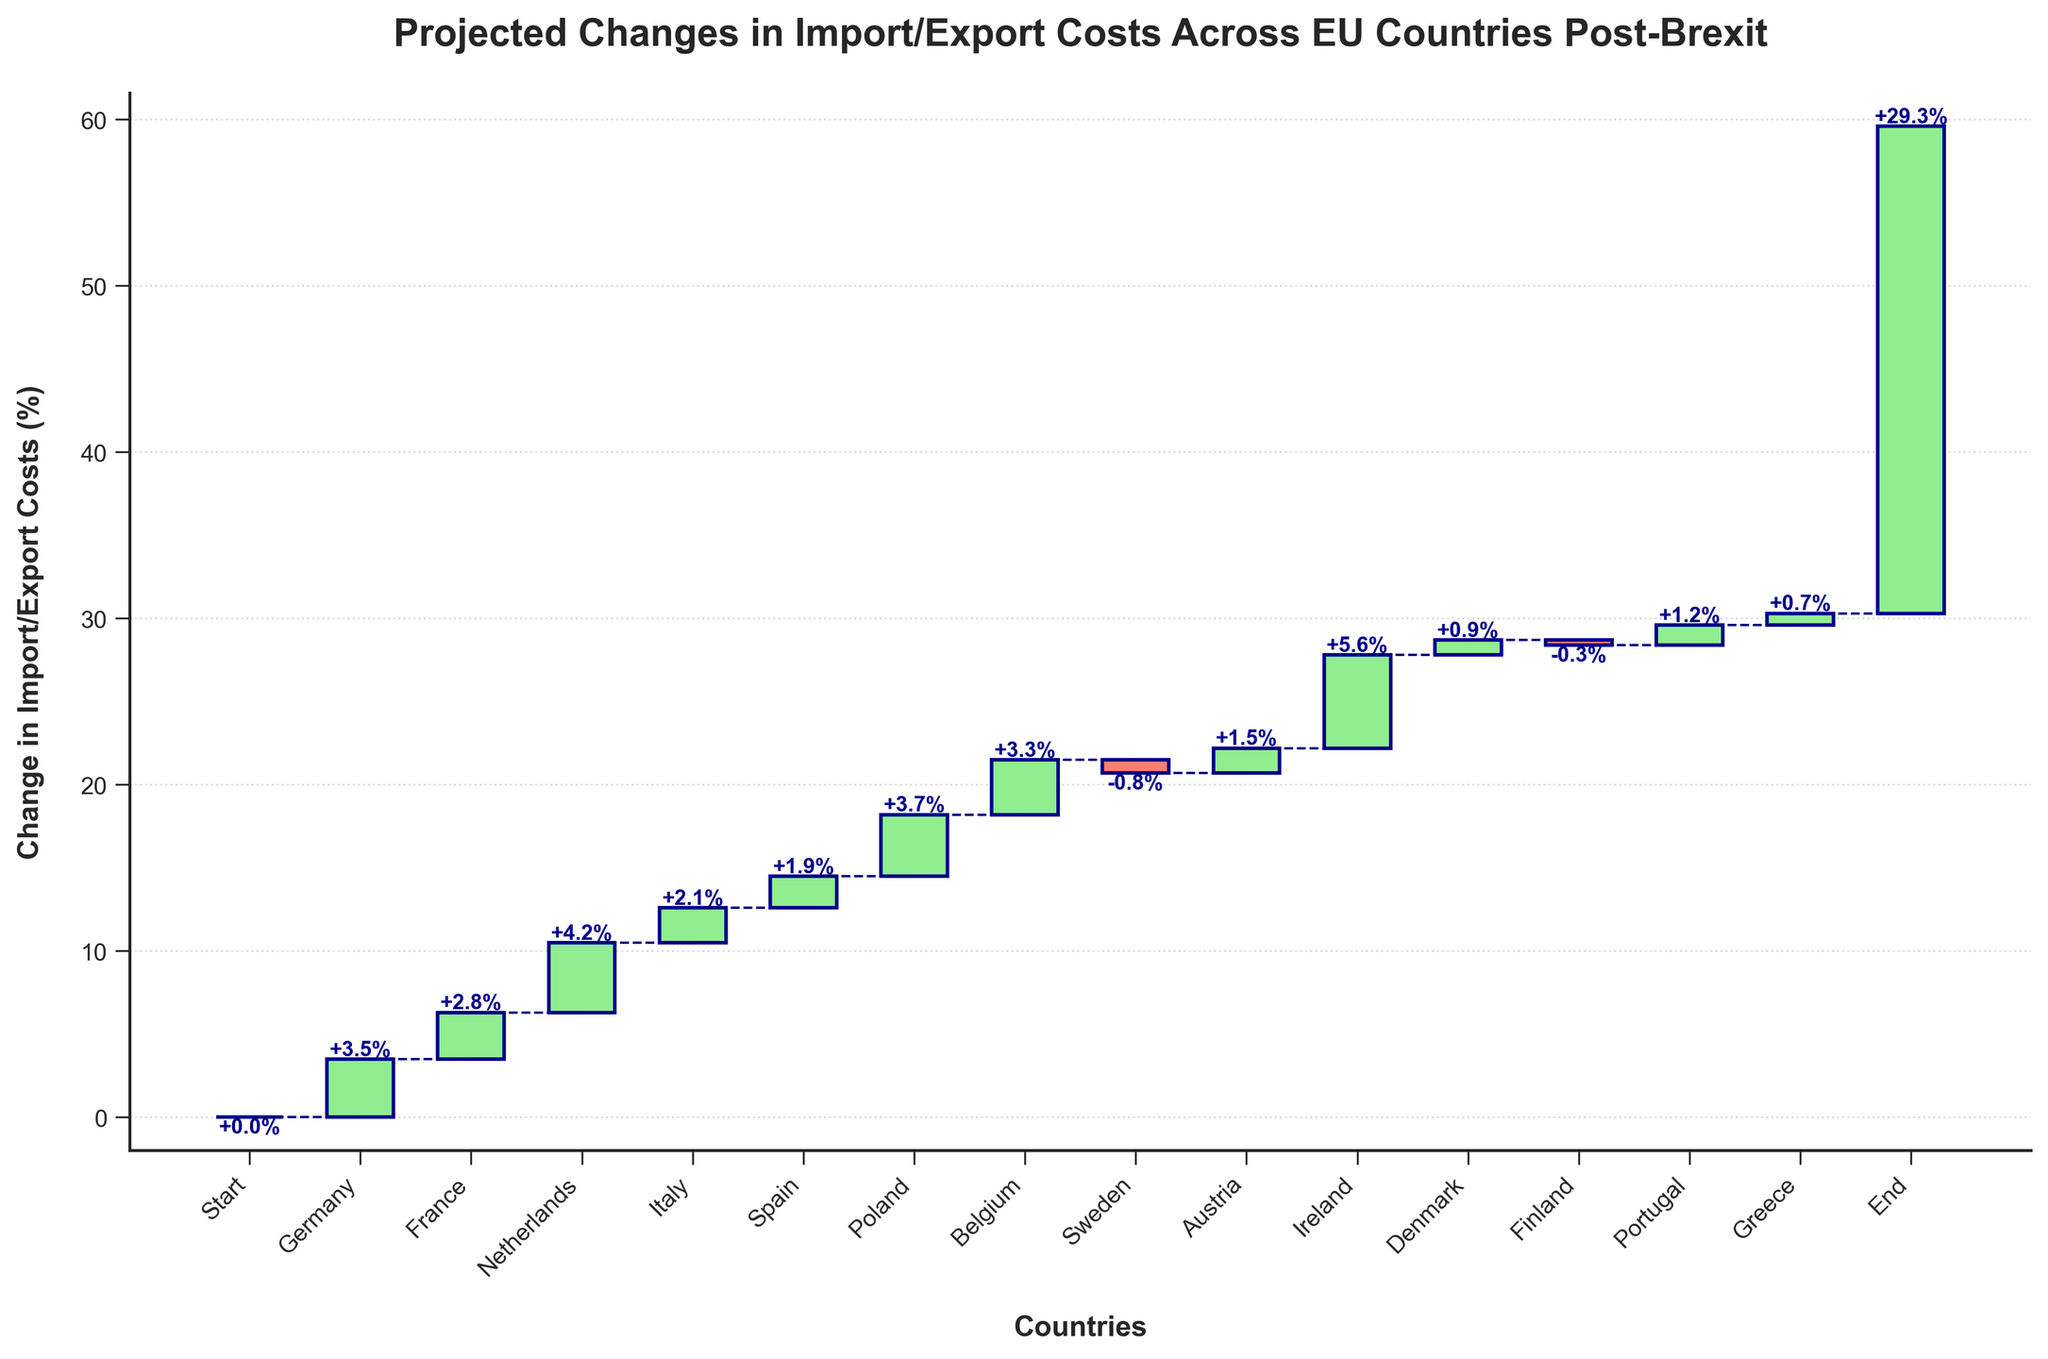What's the title of the chart? The title is usually written at the top of the chart. In this case, it reads 'Projected Changes in Import/Export Costs Across EU Countries Post-Brexit'.
Answer: Projected Changes in Import/Export Costs Across EU Countries Post-Brexit How many countries show a positive change in import/export costs? To answer this, count the number of bars that represent a positive change (colored in light green). There are 13 bars with positive changes.
Answer: 13 Which country shows the highest increase in import/export costs, and what is the percentage increase? Look at the height of the bars and the labels. The tallest bar representing the highest increase is for Ireland, with a percentage increase of 5.6%.
Answer: Ireland, 5.6% What is the cumulative change in import/export costs from the start to the end? The cumulative change is indicated by the last data point labeled as 'End'. It accumulates all the changes shown in the intermediate steps. The cumulative change is 29.3%.
Answer: 29.3% Which country is the only one with a decrease in import/export costs and what is the percentage change? Identify the bars that are in a different color (salmon) indicating a decrease. Sweden has a -0.8% change.
Answer: Sweden, -0.8% What is the average change in import/export costs among all the mentioned EU countries excluding the start and end? Sum the values and divide by the number of countries. The total sum is 3.5 + 2.8 + 4.2 + 2.1 + 1.9 + 3.7 + 3.3 + (-0.8) + 1.5 + 5.6 + 0.9 + (-0.3) + 1.2 + 0.7 = 30.3. Excluding the 'Start' and 'End', there are 14 countries, so the average is 30.3 / 14 ≈ 2.16%.
Answer: ≈ 2.16% Which two countries have changes closest to each other in magnitude, and what are those changes? Compare the values of each country, looking for differences that are minimal. Denmark and Greece have changes of 0.9% and 0.7% respectively, which are close.
Answer: Denmark, 0.9%; Greece, 0.7% What is the total change contributed by countries with negative changes? Sum the values of Sweden and Finland since they are the only two with negative changes. -0.8 + (-0.3) = -1.1%.
Answer: -1.1% Which country has the smallest positive change in import/export costs and what is the percentage? Among all positive percentage changes, identify the smallest one. Greece has the smallest positive change at 0.7%.
Answer: Greece, 0.7% How much higher are the cumulative changes in import/export costs after the Netherlands compared to after France? The cumulative change after the Netherlands is calculated as 3.5 (Germany) + 2.8 (France) + 4.2 (Netherlands) = 10.5. The cumulative change after France is 3.5 (Germany) + 2.8 (France) = 6.3. The difference is 10.5 - 6.3 = 4.2%.
Answer: 4.2% 